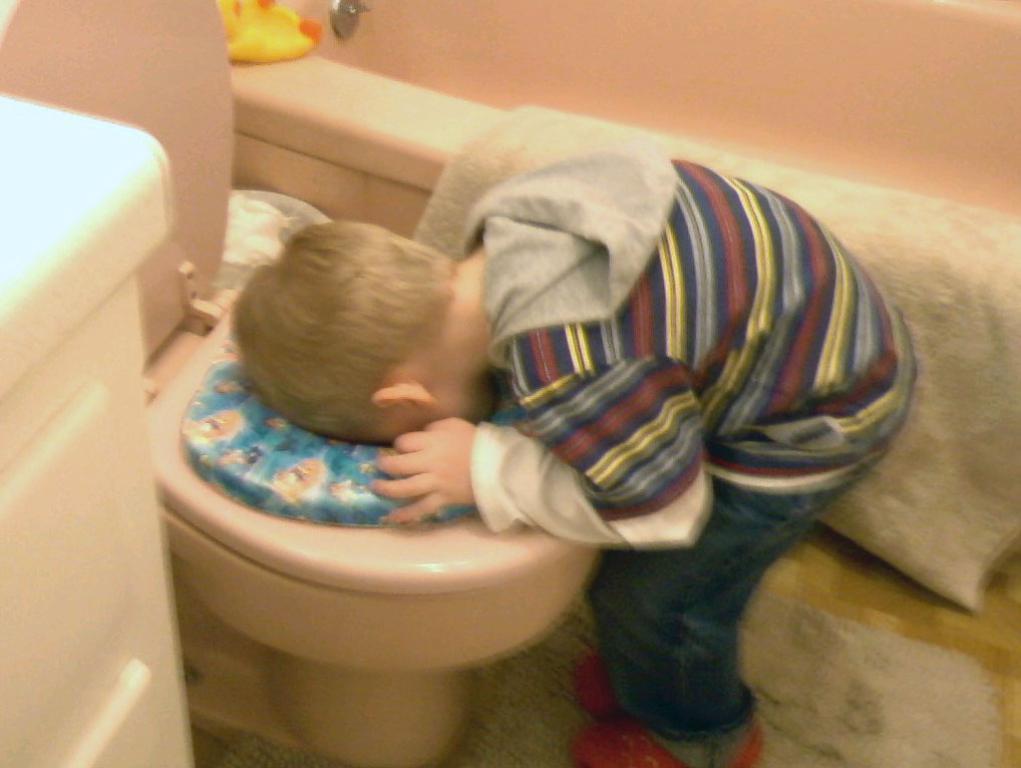Can you describe this image briefly? In this image we can see a commode and a boy. 